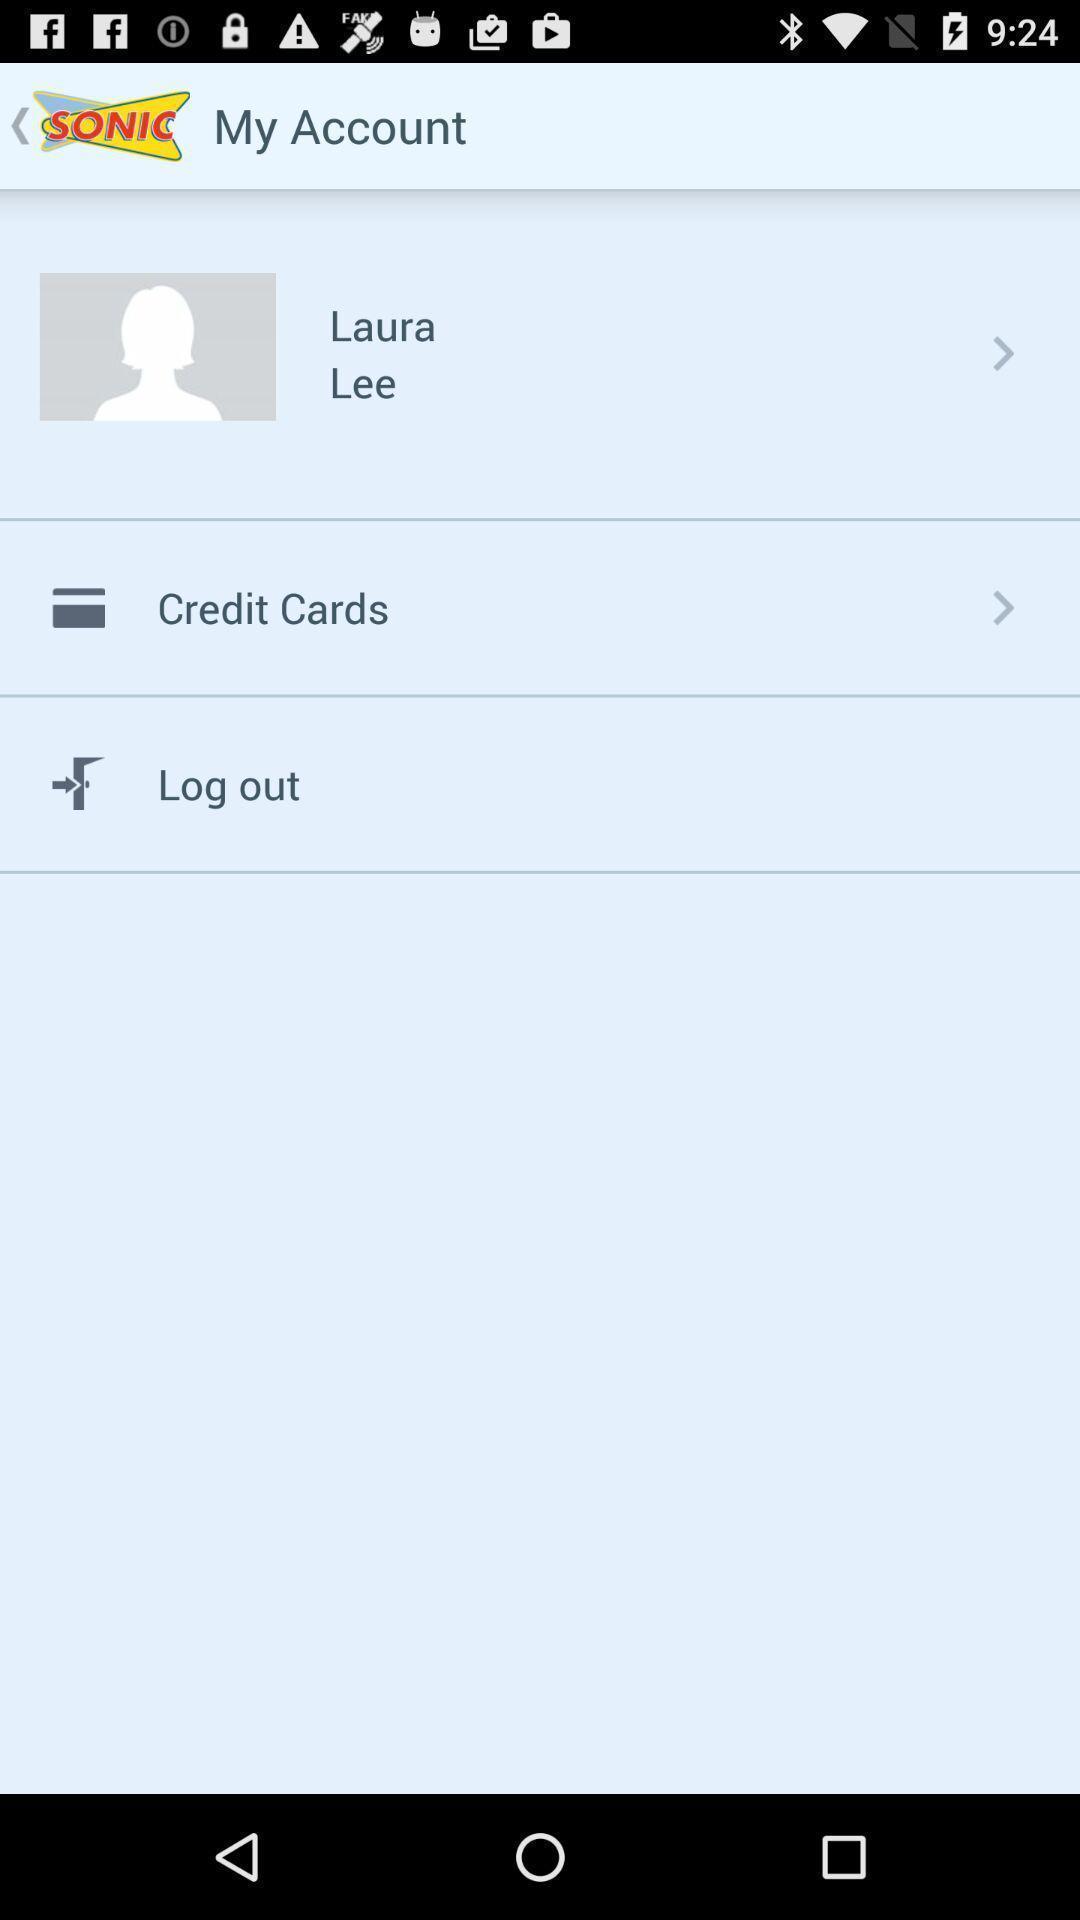Provide a textual representation of this image. Page showing profile. 